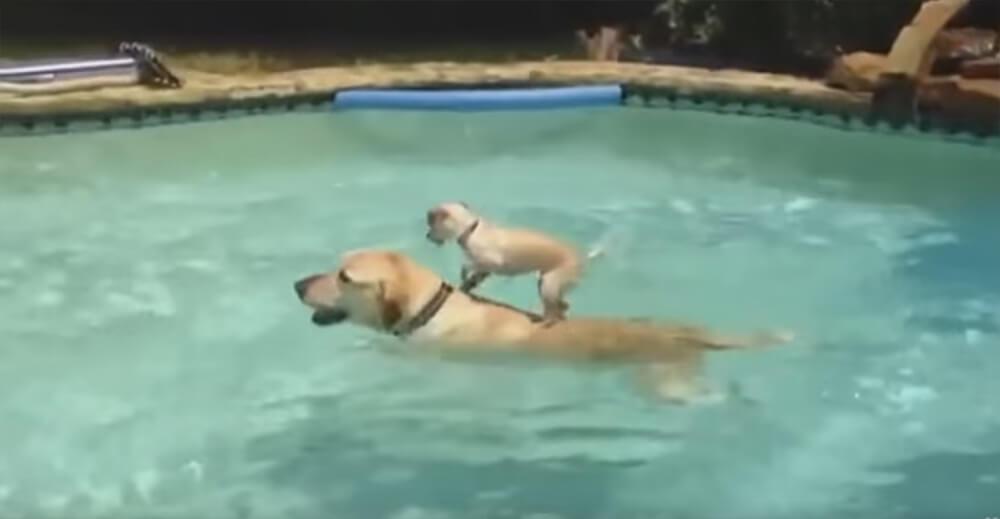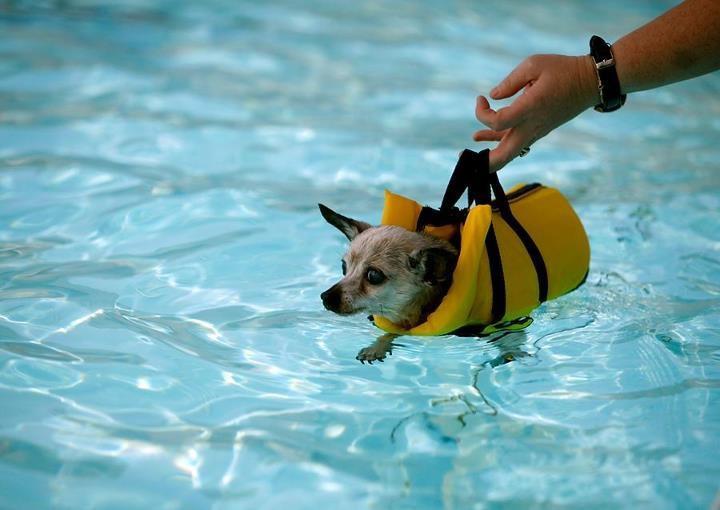The first image is the image on the left, the second image is the image on the right. For the images displayed, is the sentence "There are two dogs in the pictures." factually correct? Answer yes or no. No. 